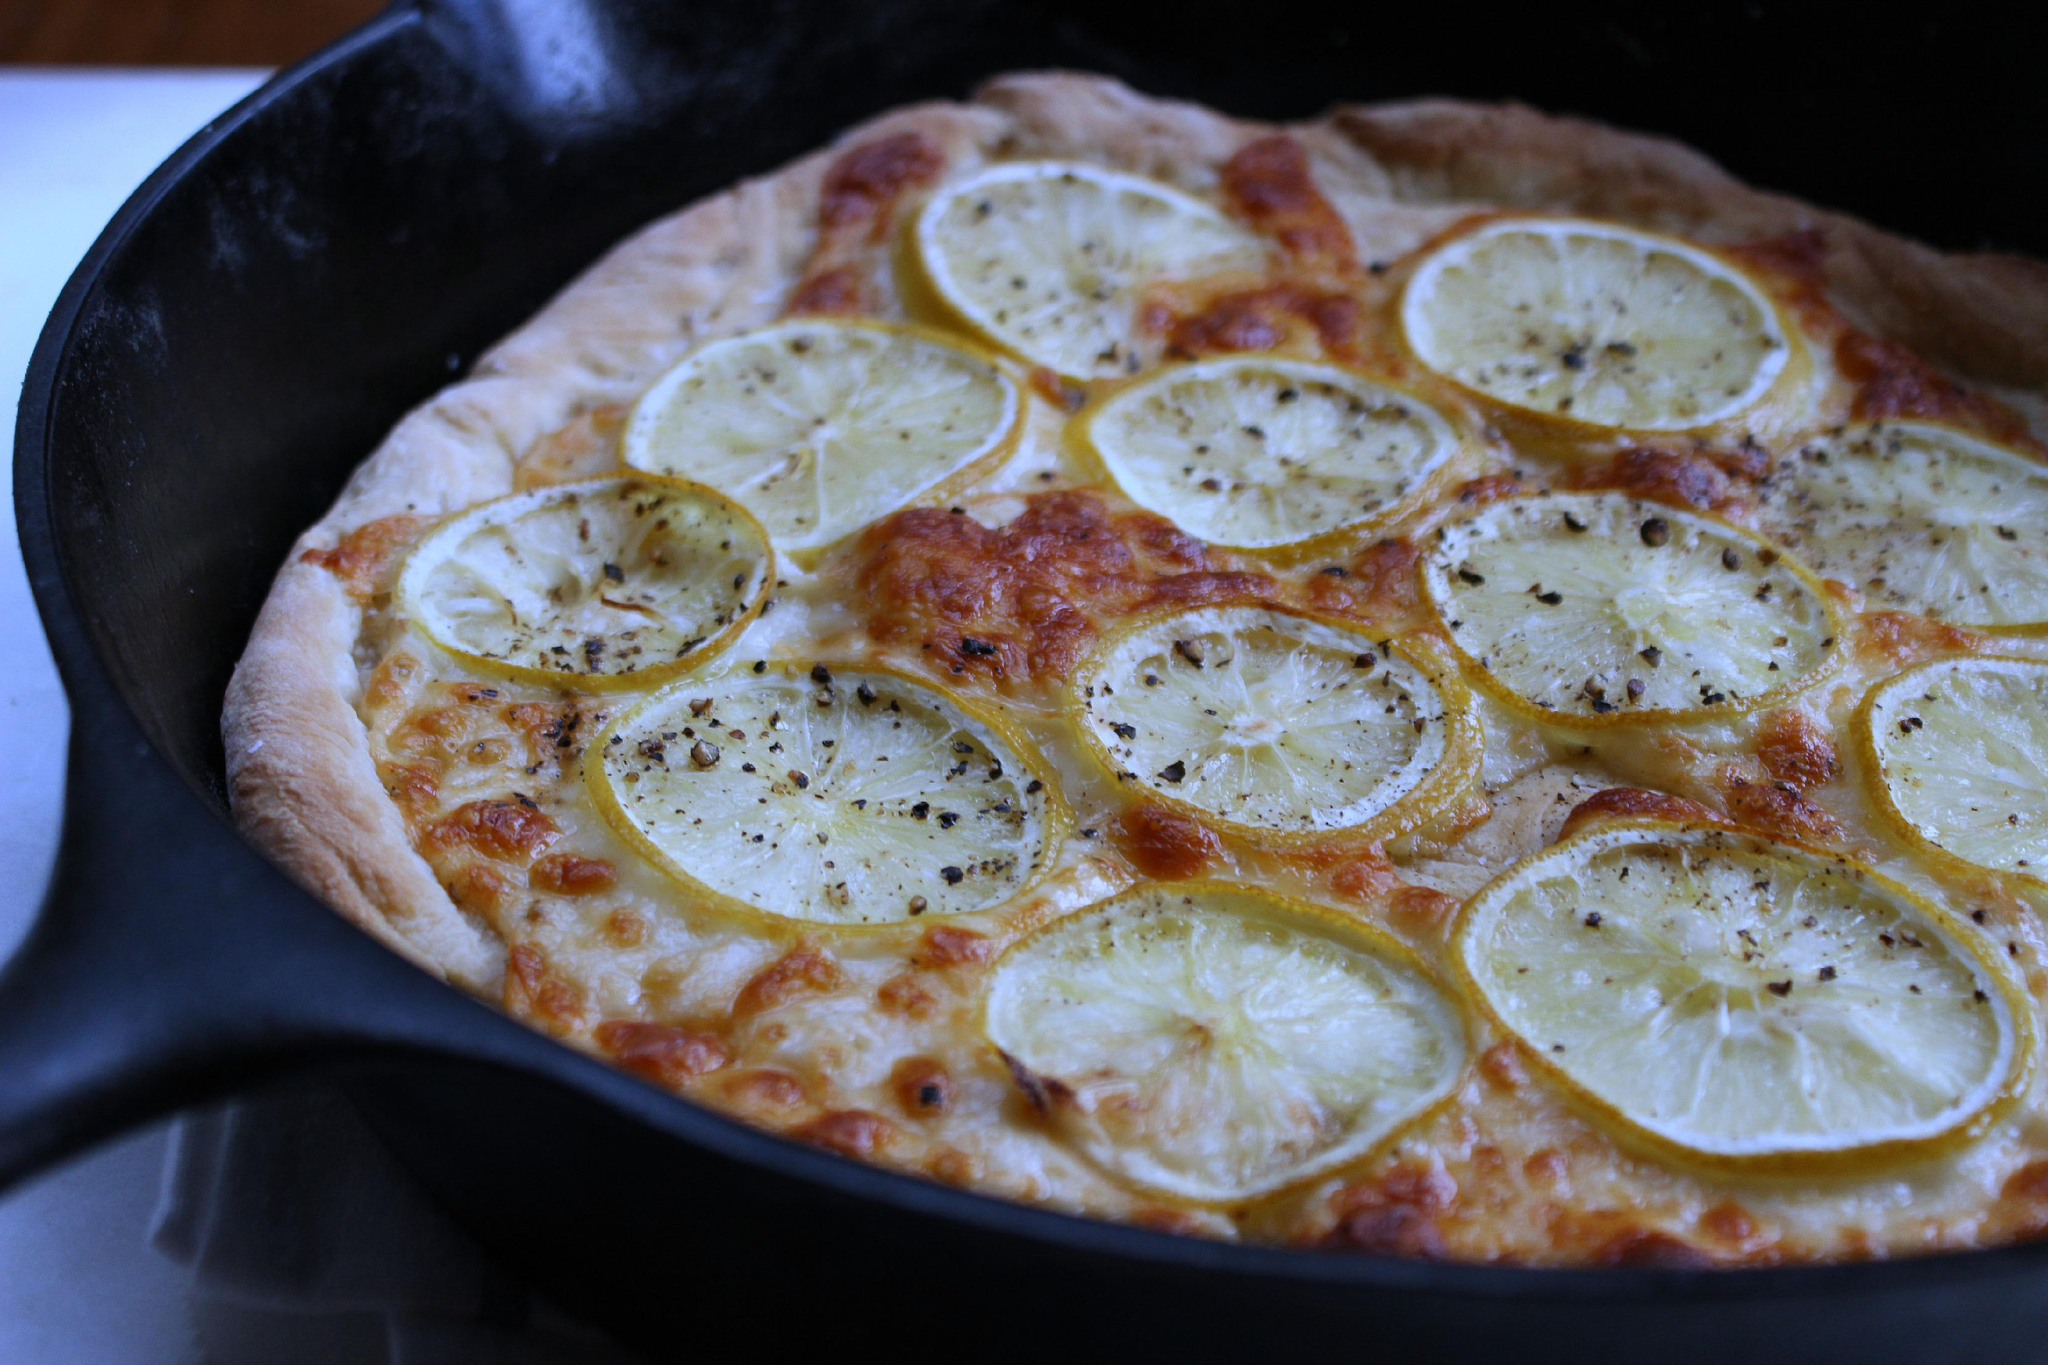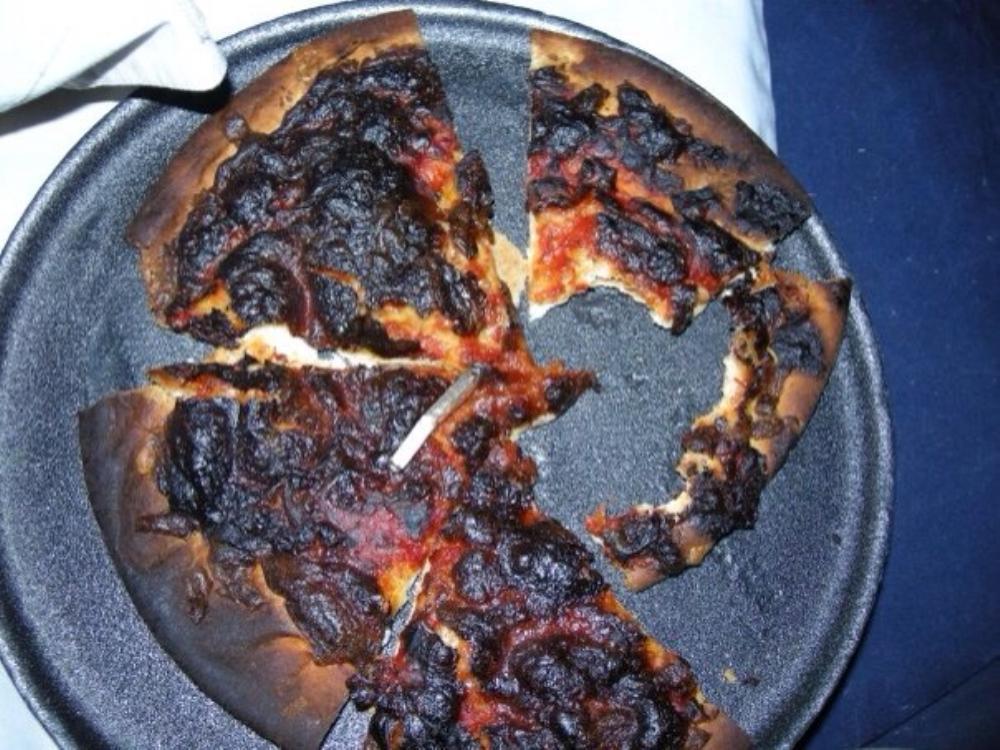The first image is the image on the left, the second image is the image on the right. Evaluate the accuracy of this statement regarding the images: "There is at least one lemon on top of the pizza.". Is it true? Answer yes or no. Yes. The first image is the image on the left, the second image is the image on the right. For the images shown, is this caption "The pizza on the left has citrus on top." true? Answer yes or no. Yes. 